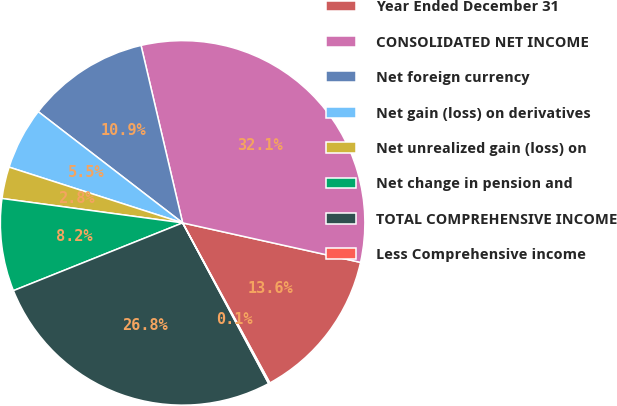<chart> <loc_0><loc_0><loc_500><loc_500><pie_chart><fcel>Year Ended December 31<fcel>CONSOLIDATED NET INCOME<fcel>Net foreign currency<fcel>Net gain (loss) on derivatives<fcel>Net unrealized gain (loss) on<fcel>Net change in pension and<fcel>TOTAL COMPREHENSIVE INCOME<fcel>Less Comprehensive income<nl><fcel>13.58%<fcel>32.14%<fcel>10.89%<fcel>5.5%<fcel>2.81%<fcel>8.2%<fcel>26.76%<fcel>0.12%<nl></chart> 